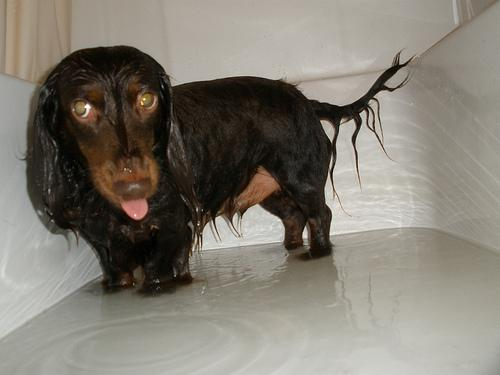Question: who is in the bathtub?
Choices:
A. A cat.
B. A boy.
C. A girl.
D. A dog.
Answer with the letter. Answer: D Question: why is the dog wet?
Choices:
A. It's in a pool.
B. Sprayed with hose.
C. It was in the rain.
D. Because its in water.
Answer with the letter. Answer: D Question: what sex is the dog?
Choices:
A. A boy.
B. A girl.
C. Female.
D. Male.
Answer with the letter. Answer: B Question: where was the picture taken?
Choices:
A. At a home.
B. By the beach.
C. In a bathtub.
D. On a boat.
Answer with the letter. Answer: C 